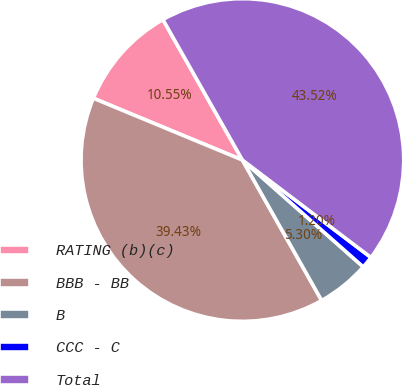Convert chart. <chart><loc_0><loc_0><loc_500><loc_500><pie_chart><fcel>RATING (b)(c)<fcel>BBB - BB<fcel>B<fcel>CCC - C<fcel>Total<nl><fcel>10.55%<fcel>39.43%<fcel>5.3%<fcel>1.2%<fcel>43.52%<nl></chart> 